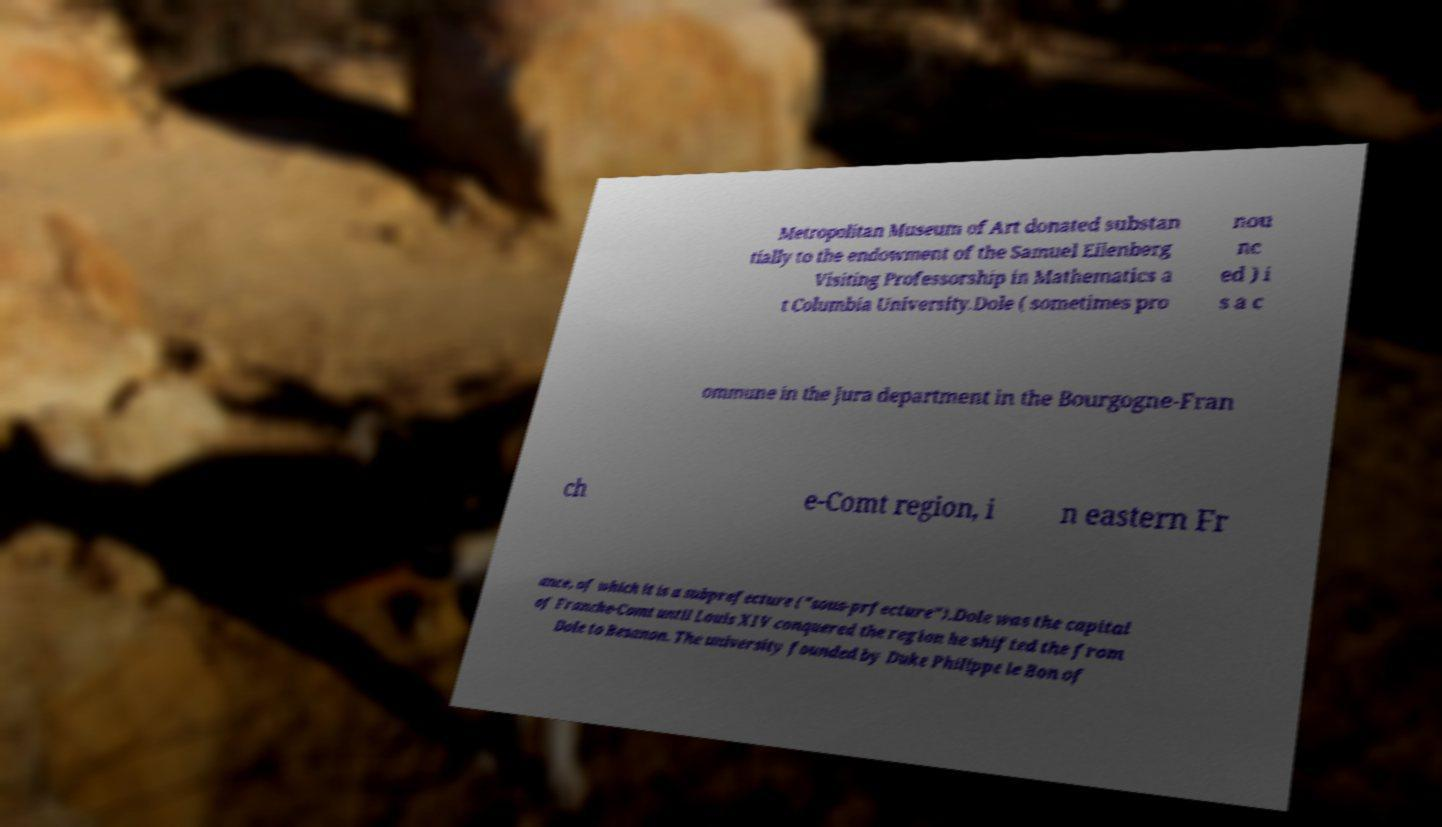I need the written content from this picture converted into text. Can you do that? Metropolitan Museum of Art donated substan tially to the endowment of the Samuel Eilenberg Visiting Professorship in Mathematics a t Columbia University.Dole ( sometimes pro nou nc ed ) i s a c ommune in the Jura department in the Bourgogne-Fran ch e-Comt region, i n eastern Fr ance, of which it is a subprefecture ("sous-prfecture").Dole was the capital of Franche-Comt until Louis XIV conquered the region he shifted the from Dole to Besanon. The university founded by Duke Philippe le Bon of 